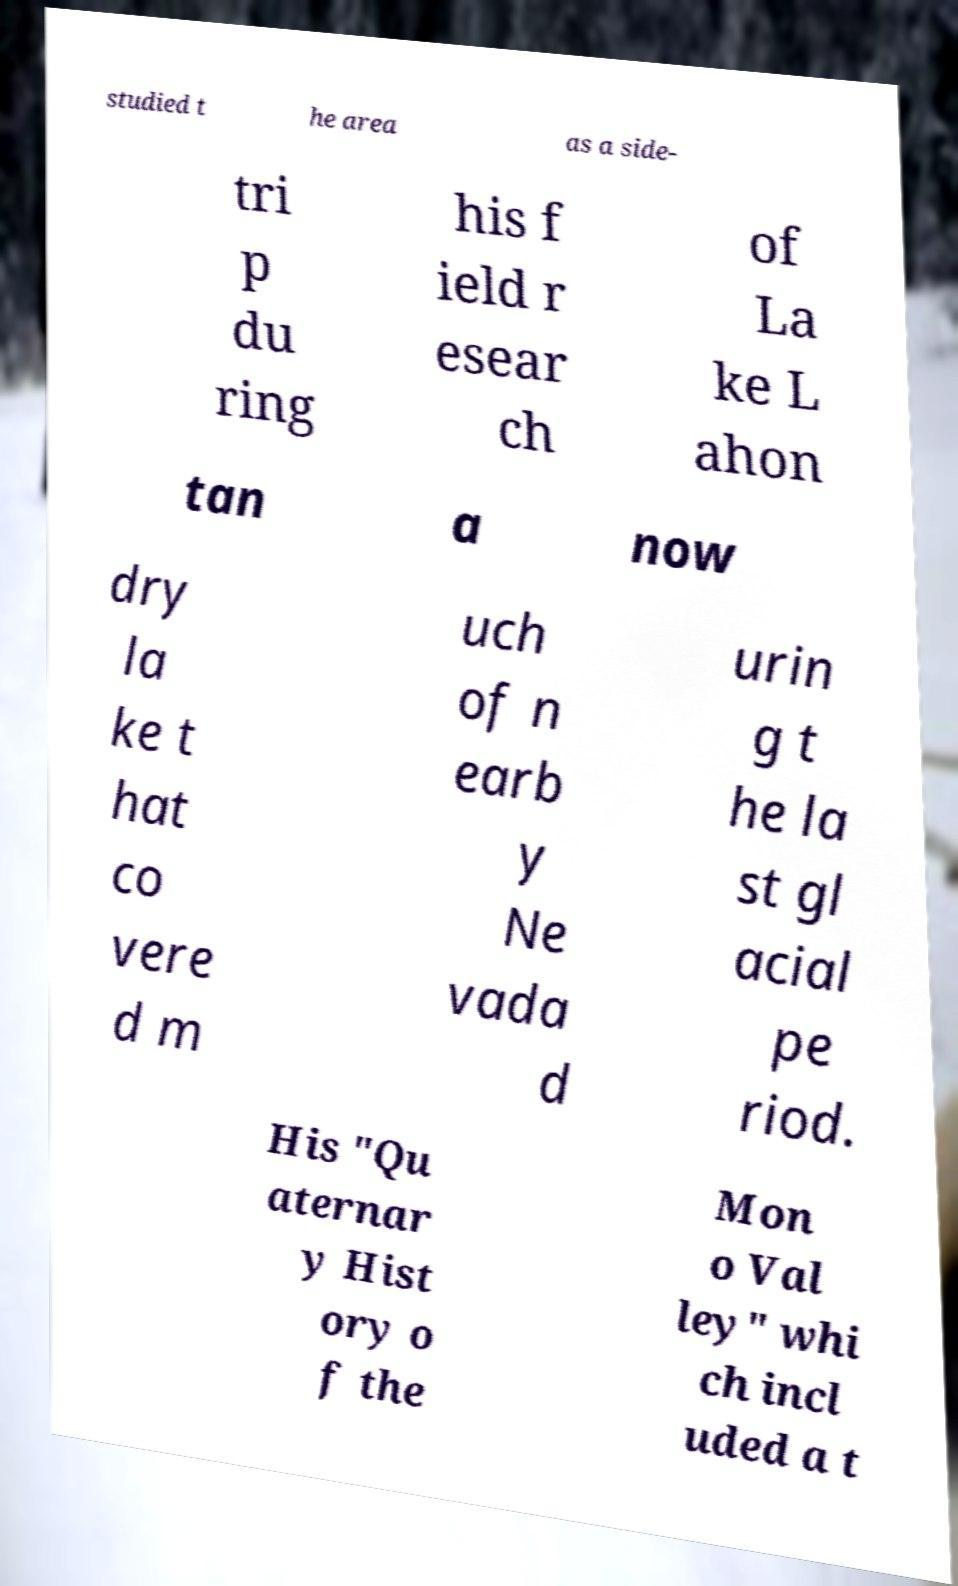Can you read and provide the text displayed in the image?This photo seems to have some interesting text. Can you extract and type it out for me? studied t he area as a side- tri p du ring his f ield r esear ch of La ke L ahon tan a now dry la ke t hat co vere d m uch of n earb y Ne vada d urin g t he la st gl acial pe riod. His "Qu aternar y Hist ory o f the Mon o Val ley" whi ch incl uded a t 